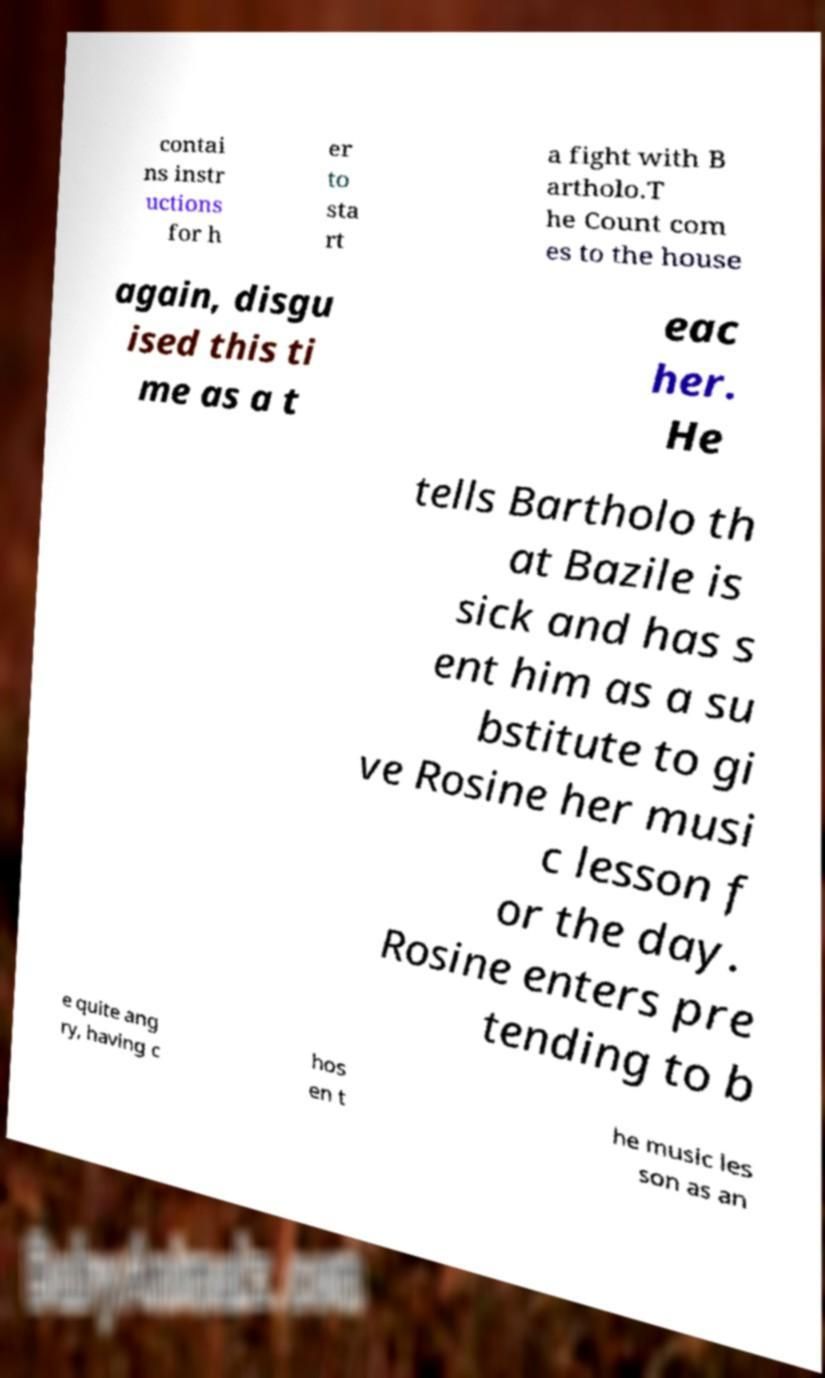Can you read and provide the text displayed in the image?This photo seems to have some interesting text. Can you extract and type it out for me? contai ns instr uctions for h er to sta rt a fight with B artholo.T he Count com es to the house again, disgu ised this ti me as a t eac her. He tells Bartholo th at Bazile is sick and has s ent him as a su bstitute to gi ve Rosine her musi c lesson f or the day. Rosine enters pre tending to b e quite ang ry, having c hos en t he music les son as an 